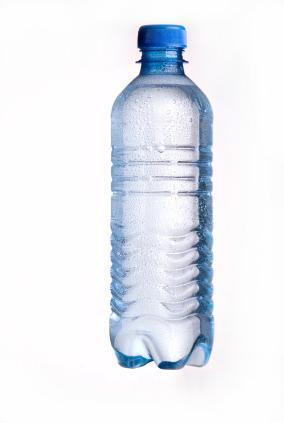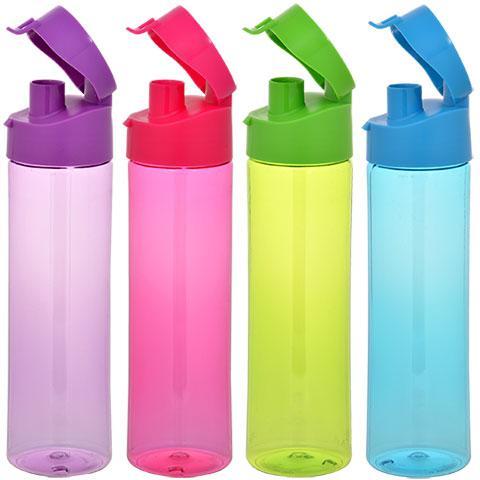The first image is the image on the left, the second image is the image on the right. Evaluate the accuracy of this statement regarding the images: "One image contains a single upright bottle with an indented 'hourglass' ribbed bottom, a paper label and a white lid, and the other image includes an upright blue-lidded label-less bottled with ribbing but no 'hourglass' indentation.". Is it true? Answer yes or no. No. The first image is the image on the left, the second image is the image on the right. Assess this claim about the two images: "There are exactly two bottles.". Correct or not? Answer yes or no. No. 